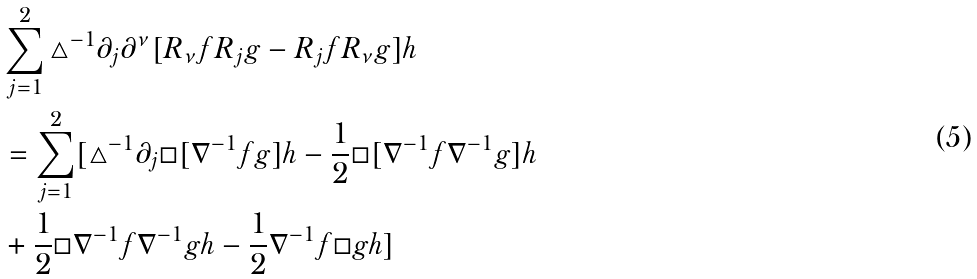Convert formula to latex. <formula><loc_0><loc_0><loc_500><loc_500>& \sum _ { j = 1 } ^ { 2 } \triangle ^ { - 1 } \partial _ { j } \partial ^ { \nu } [ R _ { \nu } f R _ { j } g - R _ { j } f R _ { \nu } g ] h \\ & = \sum _ { j = 1 } ^ { 2 } [ \triangle ^ { - 1 } \partial _ { j } \Box [ \nabla ^ { - 1 } f g ] h - \frac { 1 } { 2 } \Box [ \nabla ^ { - 1 } f \nabla ^ { - 1 } g ] h \\ & + \frac { 1 } { 2 } \Box \nabla ^ { - 1 } f \nabla ^ { - 1 } g h - \frac { 1 } { 2 } \nabla ^ { - 1 } f \Box g h ] \\</formula> 